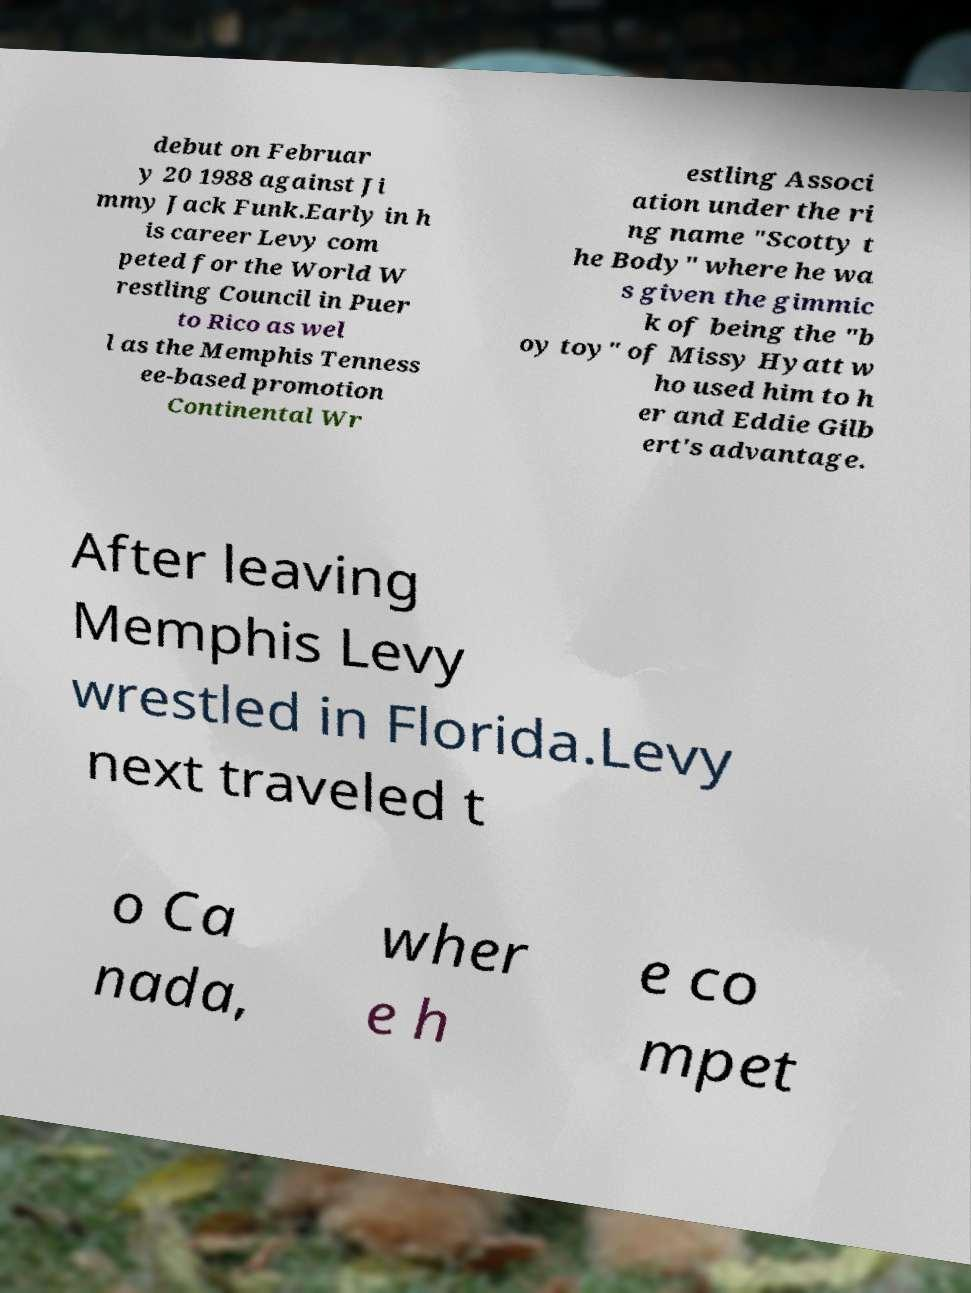Can you read and provide the text displayed in the image?This photo seems to have some interesting text. Can you extract and type it out for me? debut on Februar y 20 1988 against Ji mmy Jack Funk.Early in h is career Levy com peted for the World W restling Council in Puer to Rico as wel l as the Memphis Tenness ee-based promotion Continental Wr estling Associ ation under the ri ng name "Scotty t he Body" where he wa s given the gimmic k of being the "b oy toy" of Missy Hyatt w ho used him to h er and Eddie Gilb ert's advantage. After leaving Memphis Levy wrestled in Florida.Levy next traveled t o Ca nada, wher e h e co mpet 